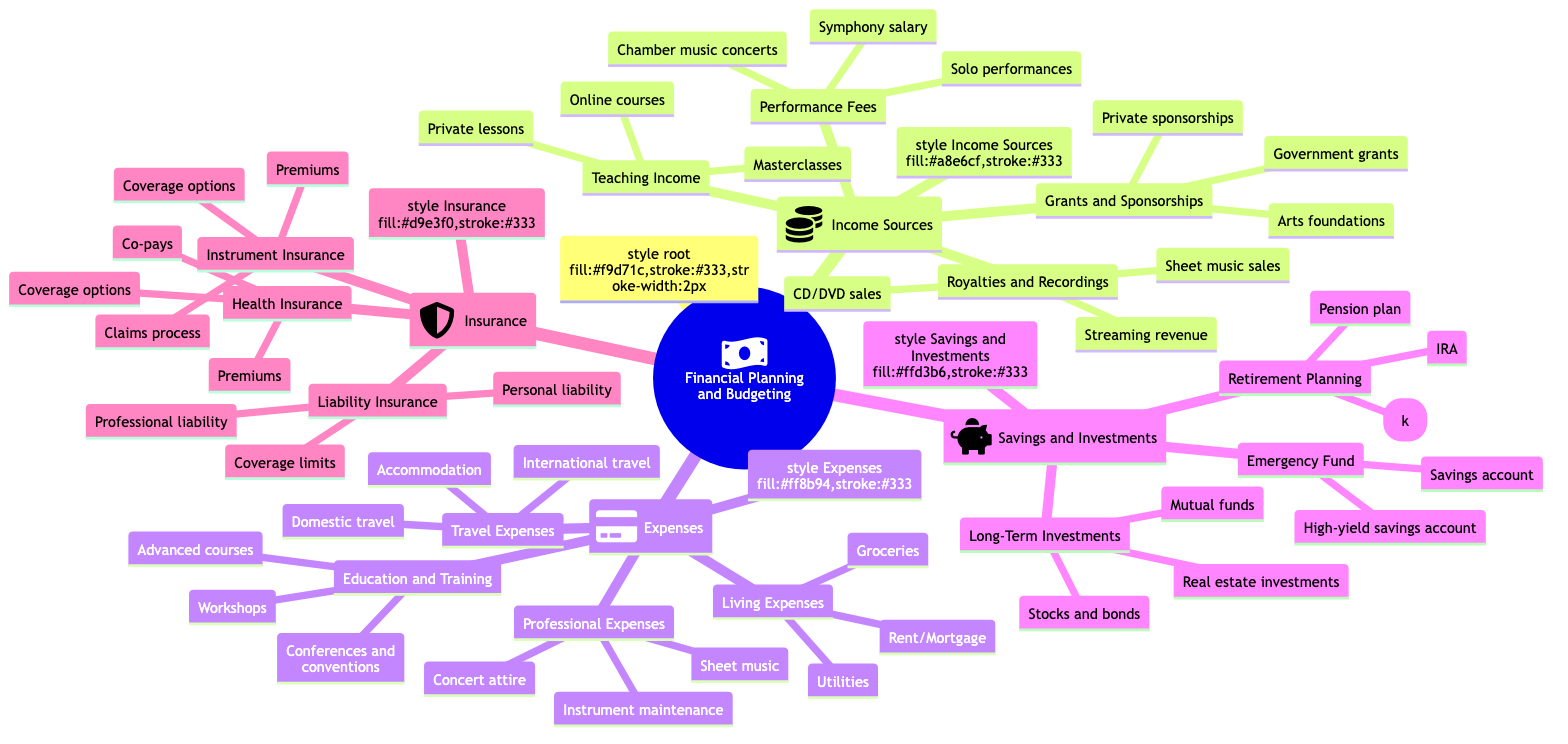What are three sources of income for musicians? The diagram lists four categories under "Income Sources" with examples. Among these, "Performance Fees," "Teaching Income," "Grants and Sponsorships," and "Royalties and Recordings" are provided. Examples from "Performance Fees" are noted as a source like "Symphony salary," "Solo performances," and "Chamber music concerts." Any three of these can be accepted as an answer.
Answer: Performance Fees, Teaching Income, Grants and Sponsorships What type of expenses are included under "Professional Expenses"? The "Expenses" node contains various categories. Within the sub-node "Professional Expenses," three items are listed: "Instrument maintenance," "Sheet music," and "Concert attire." Thus, this directly describes what is found under "Professional Expenses."
Answer: Instrument maintenance, Sheet music, Concert attire How many categories of Insurance are mentioned? The main category "Insurance" branches into three sub-categories: "Health Insurance," "Instrument Insurance," and "Liability Insurance." By counting these three, we find the total number of subcategories under Insurance.
Answer: 3 What is one way to save for retirement according to the diagram? Under the "Savings and Investments" section, there is a sub-category specifically for "Retirement Planning," which lists three options, including "IRA," "401(k)," and "Pension plan." Any of these can be identified as a method for saving for retirement.
Answer: IRA What are the different types of travel expenses mentioned in the diagram? The node "Travel Expenses" features three specific types of expenses listed under it: "Domestic travel," "International travel," and "Accommodation." These detail the various travel-related costs musicians might encounter.
Answer: Domestic travel, International travel, Accommodation What connections exist between "Grants and Sponsorships" and "Income Sources"? The "Grants and Sponsorships" sub-node is part of the higher level of "Income Sources." This indicates it is one of the branches contributing to the overall financial income category essential for musicians. Both belong to the same hierarchical structure, affirming that grants and sponsorships are a source of income.
Answer: Grants and Sponsorships is a branch under Income Sources Which category debuts with an icon representing savings? The "Savings and Investments" category is distinctively marked with an icon, specifically representing the act of saving, typically a piggy bank. This differentiates it from other categories that carry different icons.
Answer: Savings and Investments What is a common work-related expense for musicians? Within the "Professional Expenses" section of "Expenses," "Instrument maintenance" is a key example of a work-related expense that musicians must manage. This reflects a necessary cost directly associated with their profession.
Answer: Instrument maintenance 